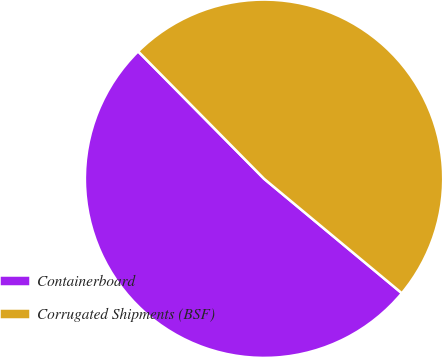Convert chart. <chart><loc_0><loc_0><loc_500><loc_500><pie_chart><fcel>Containerboard<fcel>Corrugated Shipments (BSF)<nl><fcel>51.56%<fcel>48.44%<nl></chart> 